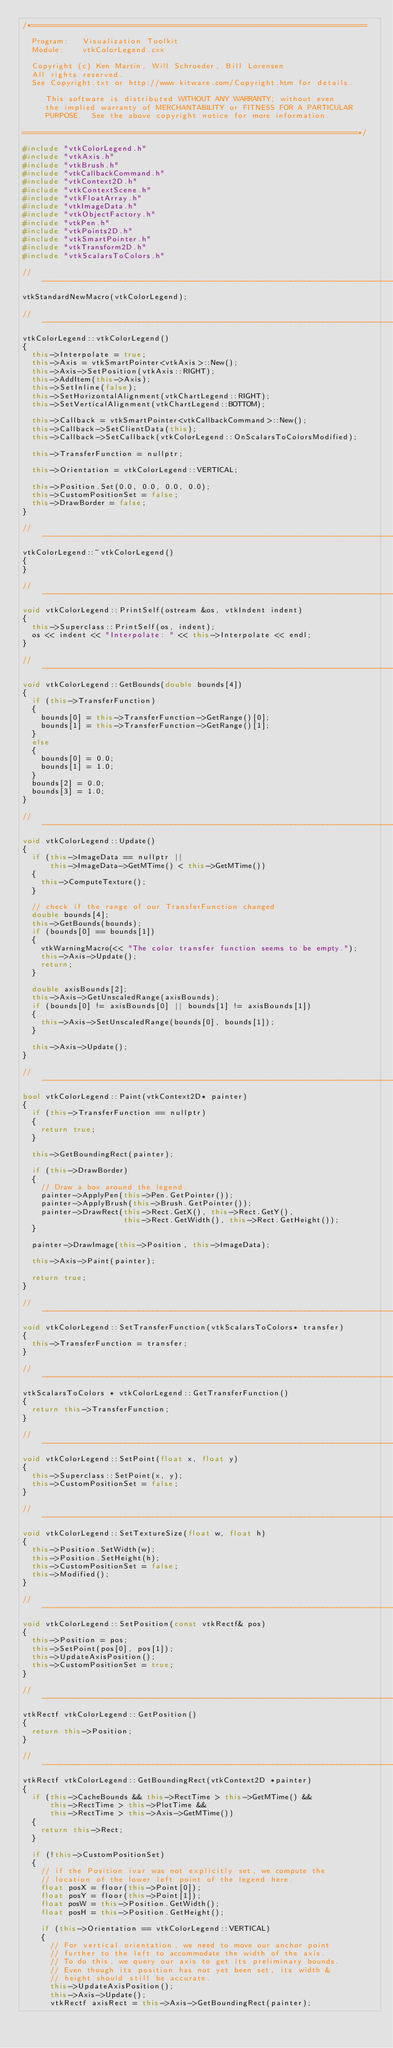Convert code to text. <code><loc_0><loc_0><loc_500><loc_500><_C++_>/*=========================================================================

  Program:   Visualization Toolkit
  Module:    vtkColorLegend.cxx

  Copyright (c) Ken Martin, Will Schroeder, Bill Lorensen
  All rights reserved.
  See Copyright.txt or http://www.kitware.com/Copyright.htm for details.

     This software is distributed WITHOUT ANY WARRANTY; without even
     the implied warranty of MERCHANTABILITY or FITNESS FOR A PARTICULAR
     PURPOSE.  See the above copyright notice for more information.

=========================================================================*/

#include "vtkColorLegend.h"
#include "vtkAxis.h"
#include "vtkBrush.h"
#include "vtkCallbackCommand.h"
#include "vtkContext2D.h"
#include "vtkContextScene.h"
#include "vtkFloatArray.h"
#include "vtkImageData.h"
#include "vtkObjectFactory.h"
#include "vtkPen.h"
#include "vtkPoints2D.h"
#include "vtkSmartPointer.h"
#include "vtkTransform2D.h"
#include "vtkScalarsToColors.h"

//-----------------------------------------------------------------------------
vtkStandardNewMacro(vtkColorLegend);

//-----------------------------------------------------------------------------
vtkColorLegend::vtkColorLegend()
{
  this->Interpolate = true;
  this->Axis = vtkSmartPointer<vtkAxis>::New();
  this->Axis->SetPosition(vtkAxis::RIGHT);
  this->AddItem(this->Axis);
  this->SetInline(false);
  this->SetHorizontalAlignment(vtkChartLegend::RIGHT);
  this->SetVerticalAlignment(vtkChartLegend::BOTTOM);

  this->Callback = vtkSmartPointer<vtkCallbackCommand>::New();
  this->Callback->SetClientData(this);
  this->Callback->SetCallback(vtkColorLegend::OnScalarsToColorsModified);

  this->TransferFunction = nullptr;

  this->Orientation = vtkColorLegend::VERTICAL;

  this->Position.Set(0.0, 0.0, 0.0, 0.0);
  this->CustomPositionSet = false;
  this->DrawBorder = false;
}

//-----------------------------------------------------------------------------
vtkColorLegend::~vtkColorLegend()
{
}

//-----------------------------------------------------------------------------
void vtkColorLegend::PrintSelf(ostream &os, vtkIndent indent)
{
  this->Superclass::PrintSelf(os, indent);
  os << indent << "Interpolate: " << this->Interpolate << endl;
}

//-----------------------------------------------------------------------------
void vtkColorLegend::GetBounds(double bounds[4])
{
  if (this->TransferFunction)
  {
    bounds[0] = this->TransferFunction->GetRange()[0];
    bounds[1] = this->TransferFunction->GetRange()[1];
  }
  else
  {
    bounds[0] = 0.0;
    bounds[1] = 1.0;
  }
  bounds[2] = 0.0;
  bounds[3] = 1.0;
}

//-----------------------------------------------------------------------------
void vtkColorLegend::Update()
{
  if (this->ImageData == nullptr ||
      this->ImageData->GetMTime() < this->GetMTime())
  {
    this->ComputeTexture();
  }

  // check if the range of our TransferFunction changed
  double bounds[4];
  this->GetBounds(bounds);
  if (bounds[0] == bounds[1])
  {
    vtkWarningMacro(<< "The color transfer function seems to be empty.");
    this->Axis->Update();
    return;
  }

  double axisBounds[2];
  this->Axis->GetUnscaledRange(axisBounds);
  if (bounds[0] != axisBounds[0] || bounds[1] != axisBounds[1])
  {
    this->Axis->SetUnscaledRange(bounds[0], bounds[1]);
  }

  this->Axis->Update();
}

//-----------------------------------------------------------------------------
bool vtkColorLegend::Paint(vtkContext2D* painter)
{
  if (this->TransferFunction == nullptr)
  {
    return true;
  }

  this->GetBoundingRect(painter);

  if (this->DrawBorder)
  {
    // Draw a box around the legend.
    painter->ApplyPen(this->Pen.GetPointer());
    painter->ApplyBrush(this->Brush.GetPointer());
    painter->DrawRect(this->Rect.GetX(), this->Rect.GetY(),
                      this->Rect.GetWidth(), this->Rect.GetHeight());
  }

  painter->DrawImage(this->Position, this->ImageData);

  this->Axis->Paint(painter);

  return true;
}

//-----------------------------------------------------------------------------
void vtkColorLegend::SetTransferFunction(vtkScalarsToColors* transfer)
{
  this->TransferFunction = transfer;
}

//-----------------------------------------------------------------------------
vtkScalarsToColors * vtkColorLegend::GetTransferFunction()
{
  return this->TransferFunction;
}

//-----------------------------------------------------------------------------
void vtkColorLegend::SetPoint(float x, float y)
{
  this->Superclass::SetPoint(x, y);
  this->CustomPositionSet = false;
}

//-----------------------------------------------------------------------------
void vtkColorLegend::SetTextureSize(float w, float h)
{
  this->Position.SetWidth(w);
  this->Position.SetHeight(h);
  this->CustomPositionSet = false;
  this->Modified();
}

//-----------------------------------------------------------------------------
void vtkColorLegend::SetPosition(const vtkRectf& pos)
{
  this->Position = pos;
  this->SetPoint(pos[0], pos[1]);
  this->UpdateAxisPosition();
  this->CustomPositionSet = true;
}

//-----------------------------------------------------------------------------
vtkRectf vtkColorLegend::GetPosition()
{
  return this->Position;
}

//-----------------------------------------------------------------------------
vtkRectf vtkColorLegend::GetBoundingRect(vtkContext2D *painter)
{
  if (this->CacheBounds && this->RectTime > this->GetMTime() &&
      this->RectTime > this->PlotTime &&
      this->RectTime > this->Axis->GetMTime())
  {
    return this->Rect;
  }

  if (!this->CustomPositionSet)
  {
    // if the Position ivar was not explicitly set, we compute the
    // location of the lower left point of the legend here.
    float posX = floor(this->Point[0]);
    float posY = floor(this->Point[1]);
    float posW = this->Position.GetWidth();
    float posH = this->Position.GetHeight();

    if (this->Orientation == vtkColorLegend::VERTICAL)
    {
      // For vertical orientation, we need to move our anchor point
      // further to the left to accommodate the width of the axis.
      // To do this, we query our axis to get its preliminary bounds.
      // Even though its position has not yet been set, its width &
      // height should still be accurate.
      this->UpdateAxisPosition();
      this->Axis->Update();
      vtkRectf axisRect = this->Axis->GetBoundingRect(painter);</code> 